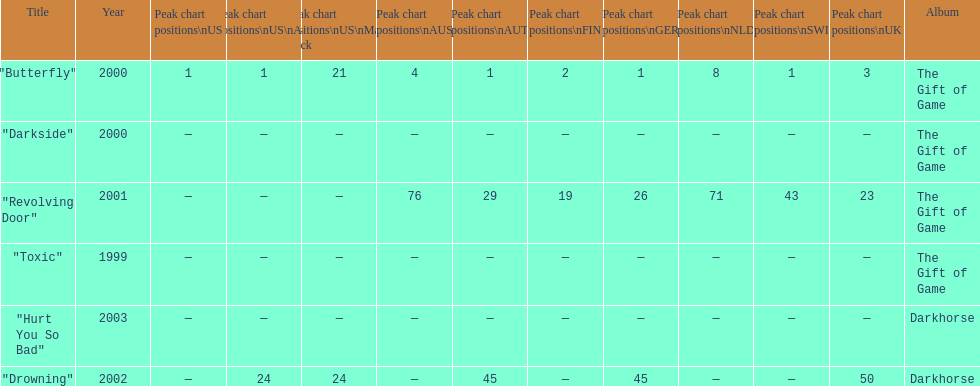Which single ranks 1 in us and 1 in us alt? "Butterfly". 